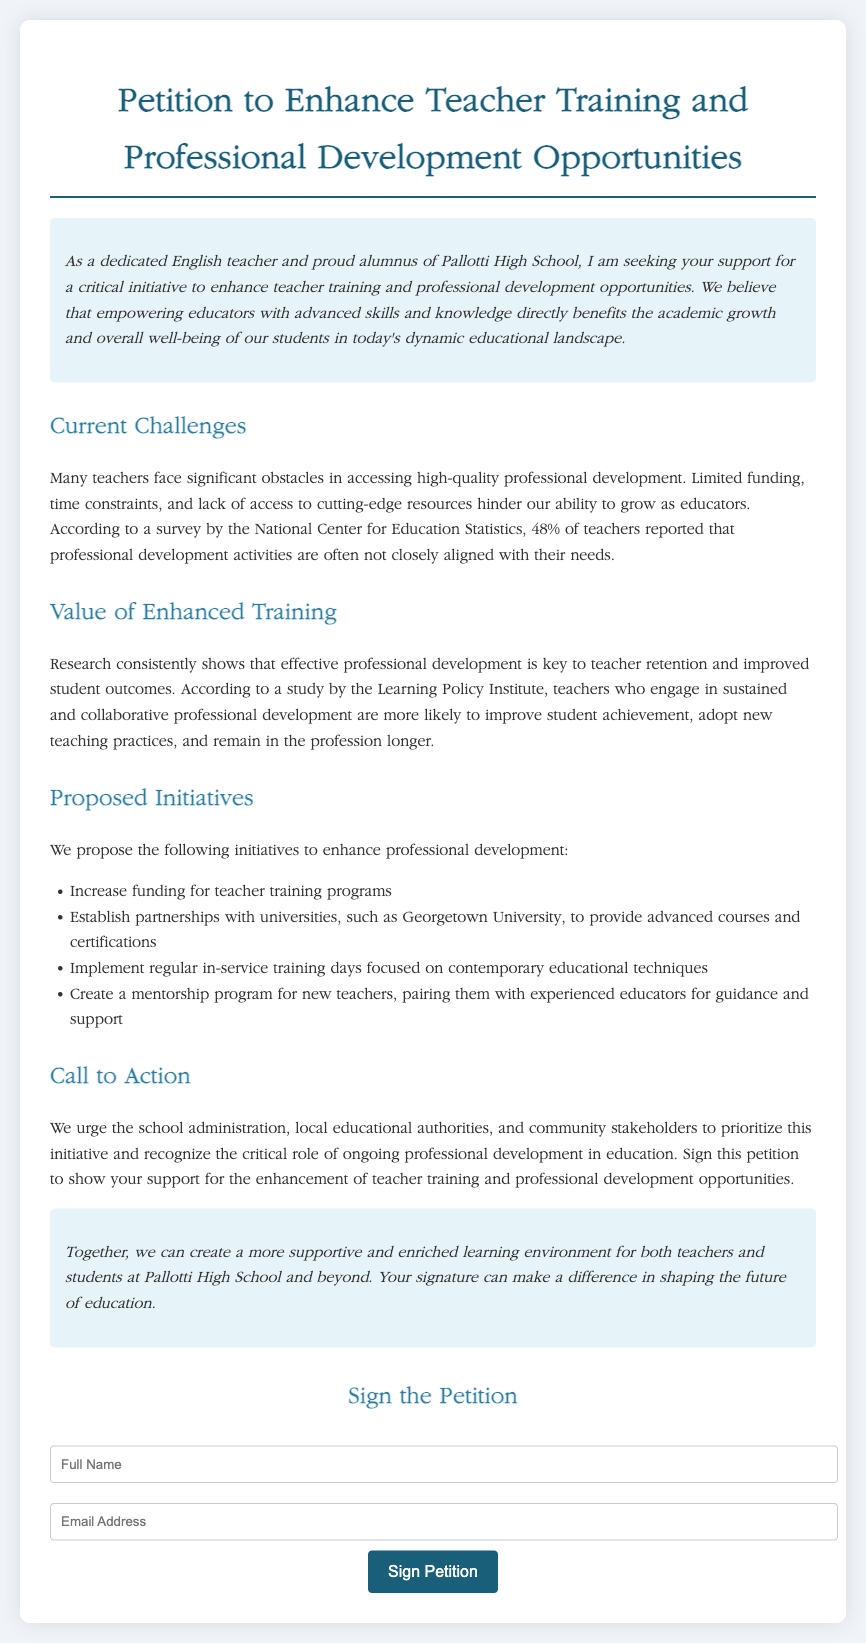What is the title of the petition? The title of the petition appears at the top of the document, stating the initiative clearly.
Answer: Petition to Enhance Teacher Training and Professional Development Opportunities What percentage of teachers reported that their professional development activities are not closely aligned with their needs? The document cites a survey by the National Center for Education Statistics regarding teachers' experiences with professional development.
Answer: 48% What university is mentioned for potential partnerships in teacher training? The document lists potential collaborations that would enhance professional development opportunities for teachers.
Answer: Georgetown University What is one proposed initiative to enhance professional development? Several initiatives are listed in the document that aims to improve teacher training and support.
Answer: Increase funding for teacher training programs What is the main call to action in the petition? The document encourages certain groups to prioritize teacher training, explicitly asking for action from the school administration and others.
Answer: Sign this petition What is the main theme of the introduction? The introduction summarizes the motivation behind the petition, emphasizing the benefits to educators and students.
Answer: Empowering educators What style of writing is used in the introduction and conclusion? The introduction and conclusion utilize a specific tone to create engagement and motivate readers.
Answer: Italic What is the intended outcome of signing the petition? The document specifies what supporters hope to achieve through the signatures collected.
Answer: Enhance teacher training and professional development opportunities 